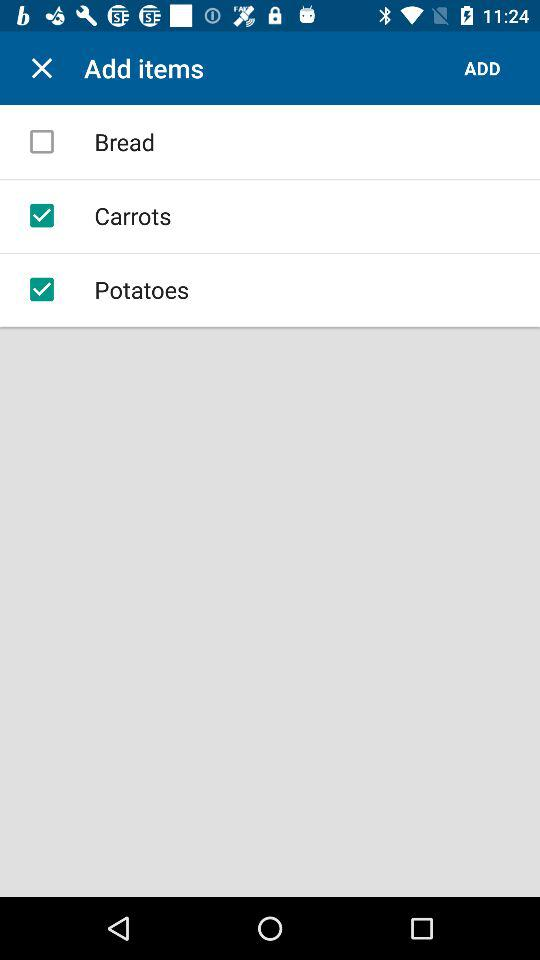What is the status of "Potatoes"? The status of "Potatoes" is "on". 